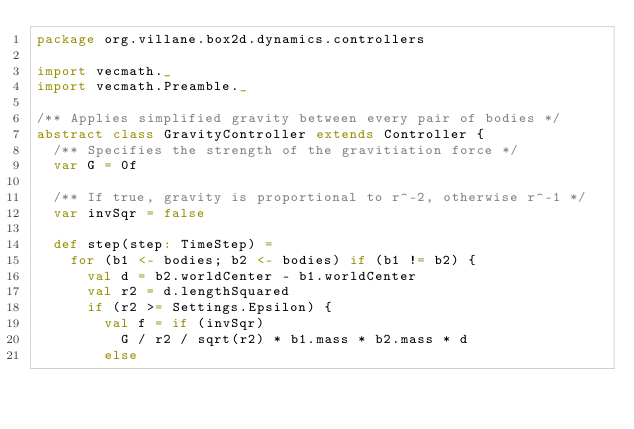<code> <loc_0><loc_0><loc_500><loc_500><_Scala_>package org.villane.box2d.dynamics.controllers

import vecmath._
import vecmath.Preamble._

/** Applies simplified gravity between every pair of bodies */
abstract class GravityController extends Controller {
  /** Specifies the strength of the gravitiation force */
  var G = 0f

  /** If true, gravity is proportional to r^-2, otherwise r^-1 */
  var invSqr = false

  def step(step: TimeStep) =
    for (b1 <- bodies; b2 <- bodies) if (b1 != b2) {
      val d = b2.worldCenter - b1.worldCenter
      val r2 = d.lengthSquared
      if (r2 >= Settings.Epsilon) {
        val f = if (invSqr)
          G / r2 / sqrt(r2) * b1.mass * b2.mass * d
        else</code> 